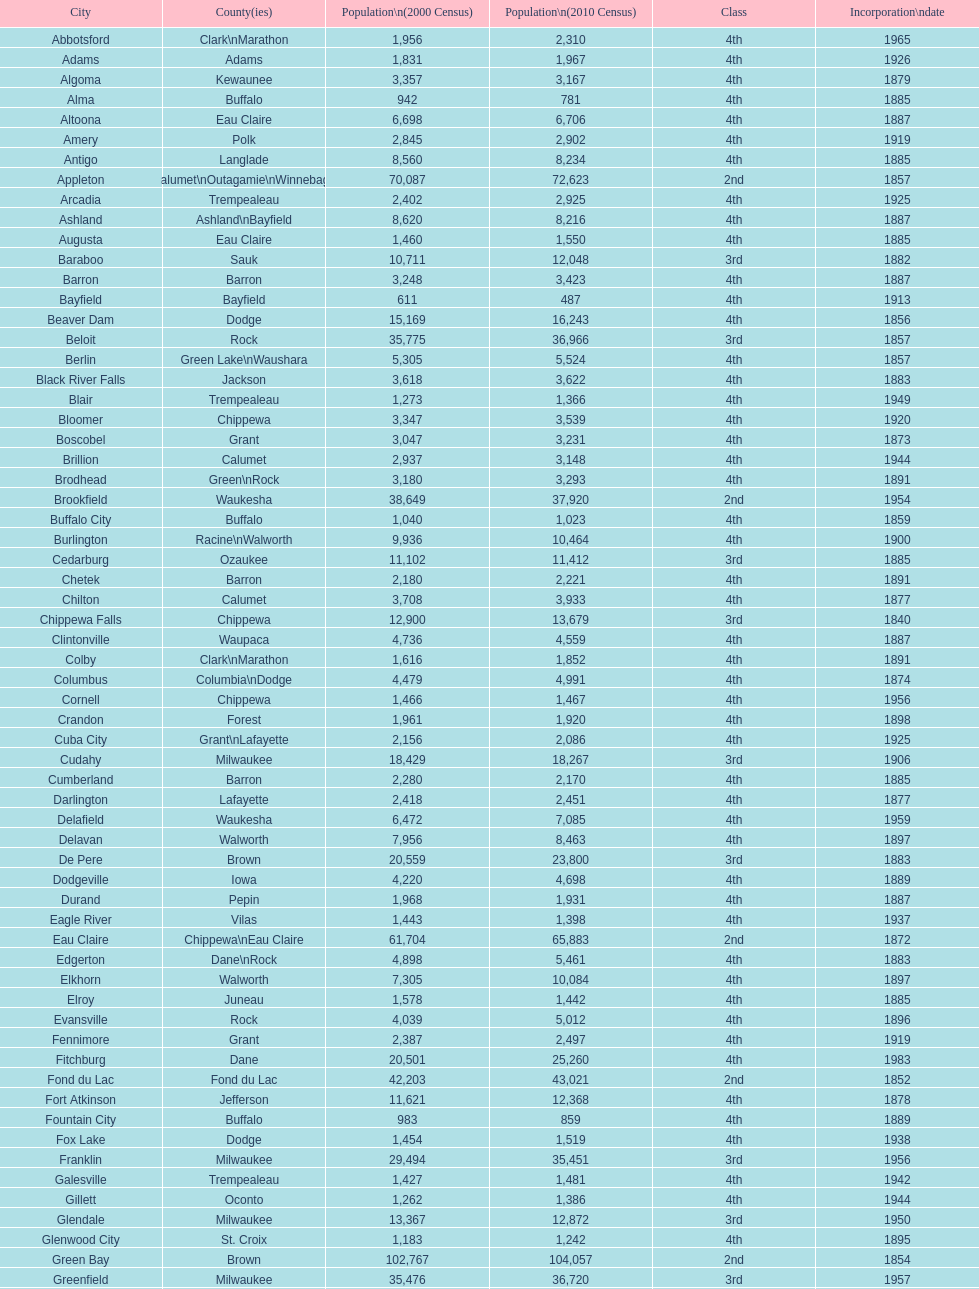What was the first city to be incorporated into wisconsin? Chippewa Falls. Write the full table. {'header': ['City', 'County(ies)', 'Population\\n(2000 Census)', 'Population\\n(2010 Census)', 'Class', 'Incorporation\\ndate'], 'rows': [['Abbotsford', 'Clark\\nMarathon', '1,956', '2,310', '4th', '1965'], ['Adams', 'Adams', '1,831', '1,967', '4th', '1926'], ['Algoma', 'Kewaunee', '3,357', '3,167', '4th', '1879'], ['Alma', 'Buffalo', '942', '781', '4th', '1885'], ['Altoona', 'Eau Claire', '6,698', '6,706', '4th', '1887'], ['Amery', 'Polk', '2,845', '2,902', '4th', '1919'], ['Antigo', 'Langlade', '8,560', '8,234', '4th', '1885'], ['Appleton', 'Calumet\\nOutagamie\\nWinnebago', '70,087', '72,623', '2nd', '1857'], ['Arcadia', 'Trempealeau', '2,402', '2,925', '4th', '1925'], ['Ashland', 'Ashland\\nBayfield', '8,620', '8,216', '4th', '1887'], ['Augusta', 'Eau Claire', '1,460', '1,550', '4th', '1885'], ['Baraboo', 'Sauk', '10,711', '12,048', '3rd', '1882'], ['Barron', 'Barron', '3,248', '3,423', '4th', '1887'], ['Bayfield', 'Bayfield', '611', '487', '4th', '1913'], ['Beaver Dam', 'Dodge', '15,169', '16,243', '4th', '1856'], ['Beloit', 'Rock', '35,775', '36,966', '3rd', '1857'], ['Berlin', 'Green Lake\\nWaushara', '5,305', '5,524', '4th', '1857'], ['Black River Falls', 'Jackson', '3,618', '3,622', '4th', '1883'], ['Blair', 'Trempealeau', '1,273', '1,366', '4th', '1949'], ['Bloomer', 'Chippewa', '3,347', '3,539', '4th', '1920'], ['Boscobel', 'Grant', '3,047', '3,231', '4th', '1873'], ['Brillion', 'Calumet', '2,937', '3,148', '4th', '1944'], ['Brodhead', 'Green\\nRock', '3,180', '3,293', '4th', '1891'], ['Brookfield', 'Waukesha', '38,649', '37,920', '2nd', '1954'], ['Buffalo City', 'Buffalo', '1,040', '1,023', '4th', '1859'], ['Burlington', 'Racine\\nWalworth', '9,936', '10,464', '4th', '1900'], ['Cedarburg', 'Ozaukee', '11,102', '11,412', '3rd', '1885'], ['Chetek', 'Barron', '2,180', '2,221', '4th', '1891'], ['Chilton', 'Calumet', '3,708', '3,933', '4th', '1877'], ['Chippewa Falls', 'Chippewa', '12,900', '13,679', '3rd', '1840'], ['Clintonville', 'Waupaca', '4,736', '4,559', '4th', '1887'], ['Colby', 'Clark\\nMarathon', '1,616', '1,852', '4th', '1891'], ['Columbus', 'Columbia\\nDodge', '4,479', '4,991', '4th', '1874'], ['Cornell', 'Chippewa', '1,466', '1,467', '4th', '1956'], ['Crandon', 'Forest', '1,961', '1,920', '4th', '1898'], ['Cuba City', 'Grant\\nLafayette', '2,156', '2,086', '4th', '1925'], ['Cudahy', 'Milwaukee', '18,429', '18,267', '3rd', '1906'], ['Cumberland', 'Barron', '2,280', '2,170', '4th', '1885'], ['Darlington', 'Lafayette', '2,418', '2,451', '4th', '1877'], ['Delafield', 'Waukesha', '6,472', '7,085', '4th', '1959'], ['Delavan', 'Walworth', '7,956', '8,463', '4th', '1897'], ['De Pere', 'Brown', '20,559', '23,800', '3rd', '1883'], ['Dodgeville', 'Iowa', '4,220', '4,698', '4th', '1889'], ['Durand', 'Pepin', '1,968', '1,931', '4th', '1887'], ['Eagle River', 'Vilas', '1,443', '1,398', '4th', '1937'], ['Eau Claire', 'Chippewa\\nEau Claire', '61,704', '65,883', '2nd', '1872'], ['Edgerton', 'Dane\\nRock', '4,898', '5,461', '4th', '1883'], ['Elkhorn', 'Walworth', '7,305', '10,084', '4th', '1897'], ['Elroy', 'Juneau', '1,578', '1,442', '4th', '1885'], ['Evansville', 'Rock', '4,039', '5,012', '4th', '1896'], ['Fennimore', 'Grant', '2,387', '2,497', '4th', '1919'], ['Fitchburg', 'Dane', '20,501', '25,260', '4th', '1983'], ['Fond du Lac', 'Fond du Lac', '42,203', '43,021', '2nd', '1852'], ['Fort Atkinson', 'Jefferson', '11,621', '12,368', '4th', '1878'], ['Fountain City', 'Buffalo', '983', '859', '4th', '1889'], ['Fox Lake', 'Dodge', '1,454', '1,519', '4th', '1938'], ['Franklin', 'Milwaukee', '29,494', '35,451', '3rd', '1956'], ['Galesville', 'Trempealeau', '1,427', '1,481', '4th', '1942'], ['Gillett', 'Oconto', '1,262', '1,386', '4th', '1944'], ['Glendale', 'Milwaukee', '13,367', '12,872', '3rd', '1950'], ['Glenwood City', 'St. Croix', '1,183', '1,242', '4th', '1895'], ['Green Bay', 'Brown', '102,767', '104,057', '2nd', '1854'], ['Greenfield', 'Milwaukee', '35,476', '36,720', '3rd', '1957'], ['Green Lake', 'Green Lake', '1,100', '960', '4th', '1962'], ['Greenwood', 'Clark', '1,079', '1,026', '4th', '1891'], ['Hartford', 'Dodge\\nWashington', '10,905', '14,223', '3rd', '1883'], ['Hayward', 'Sawyer', '2,129', '2,318', '4th', '1915'], ['Hillsboro', 'Vernon', '1,302', '1,417', '4th', '1885'], ['Horicon', 'Dodge', '3,775', '3,655', '4th', '1897'], ['Hudson', 'St. Croix', '8,775', '12,719', '4th', '1858'], ['Hurley', 'Iron', '1,818', '1,547', '4th', '1918'], ['Independence', 'Trempealeau', '1,244', '1,336', '4th', '1942'], ['Janesville', 'Rock', '59,498', '63,575', '2nd', '1853'], ['Jefferson', 'Jefferson', '7,338', '7,973', '4th', '1878'], ['Juneau', 'Dodge', '2,485', '2,814', '4th', '1887'], ['Kaukauna', 'Outagamie', '12,983', '15,462', '3rd', '1885'], ['Kenosha', 'Kenosha', '90,352', '99,218', '2nd', '1850'], ['Kewaunee', 'Kewaunee', '2,806', '2,952', '4th', '1883'], ['Kiel', 'Calumet\\nManitowoc', '3,450', '3,738', '4th', '1920'], ['La Crosse', 'La Crosse', '51,818', '51,320', '2nd', '1856'], ['Ladysmith', 'Rusk', '3,932', '3,414', '4th', '1905'], ['Lake Geneva', 'Walworth', '7,148', '7,651', '4th', '1883'], ['Lake Mills', 'Jefferson', '4,843', '5,708', '4th', '1905'], ['Lancaster', 'Grant', '4,070', '3,868', '4th', '1878'], ['Lodi', 'Columbia', '2,882', '3,050', '4th', '1941'], ['Loyal', 'Clark', '1,308', '1,261', '4th', '1948'], ['Madison', 'Dane', '208,054', '233,209', '2nd', '1856'], ['Manawa', 'Waupaca', '1,330', '1,371', '4th', '1954'], ['Manitowoc', 'Manitowoc', '34,053', '33,736', '3rd', '1870'], ['Marinette', 'Marinette', '11,749', '10,968', '3rd', '1887'], ['Marion', 'Shawano\\nWaupaca', '1,297', '1,260', '4th', '1898'], ['Markesan', 'Green Lake', '1,396', '1,476', '4th', '1959'], ['Marshfield', 'Marathon\\nWood', '18,800', '19,118', '3rd', '1883'], ['Mauston', 'Juneau', '3,740', '4,423', '4th', '1883'], ['Mayville', 'Dodge', '4,902', '5,154', '4th', '1885'], ['Medford', 'Taylor', '4,350', '4,326', '4th', '1889'], ['Mellen', 'Ashland', '845', '731', '4th', '1907'], ['Menasha', 'Calumet\\nWinnebago', '16,331', '17,353', '3rd', '1874'], ['Menomonie', 'Dunn', '14,937', '16,264', '4th', '1882'], ['Mequon', 'Ozaukee', '22,643', '23,132', '4th', '1957'], ['Merrill', 'Lincoln', '10,146', '9,661', '4th', '1883'], ['Middleton', 'Dane', '15,770', '17,442', '3rd', '1963'], ['Milton', 'Rock', '5,132', '5,546', '4th', '1969'], ['Milwaukee', 'Milwaukee\\nWashington\\nWaukesha', '596,974', '594,833', '1st', '1846'], ['Mineral Point', 'Iowa', '2,617', '2,487', '4th', '1857'], ['Mondovi', 'Buffalo', '2,634', '2,777', '4th', '1889'], ['Monona', 'Dane', '8,018', '7,533', '4th', '1969'], ['Monroe', 'Green', '10,843', '10,827', '4th', '1882'], ['Montello', 'Marquette', '1,397', '1,495', '4th', '1938'], ['Montreal', 'Iron', '838', '807', '4th', '1924'], ['Mosinee', 'Marathon', '4,063', '3,988', '4th', '1931'], ['Muskego', 'Waukesha', '21,397', '24,135', '3rd', '1964'], ['Neenah', 'Winnebago', '24,507', '25,501', '3rd', '1873'], ['Neillsville', 'Clark', '2,731', '2,463', '4th', '1882'], ['Nekoosa', 'Wood', '2,590', '2,580', '4th', '1926'], ['New Berlin', 'Waukesha', '38,220', '39,584', '3rd', '1959'], ['New Holstein', 'Calumet', '3,301', '3,236', '4th', '1889'], ['New Lisbon', 'Juneau', '1,436', '2,554', '4th', '1889'], ['New London', 'Outagamie\\nWaupaca', '7,085', '7,295', '4th', '1877'], ['New Richmond', 'St. Croix', '6,310', '8,375', '4th', '1885'], ['Niagara', 'Marinette', '1,880', '1,624', '4th', '1992'], ['Oak Creek', 'Milwaukee', '28,456', '34,451', '3rd', '1955'], ['Oconomowoc', 'Waukesha', '12,382', '15,712', '3rd', '1875'], ['Oconto', 'Oconto', '4,708', '4,513', '4th', '1869'], ['Oconto Falls', 'Oconto', '2,843', '2,891', '4th', '1919'], ['Omro', 'Winnebago', '3,177', '3,517', '4th', '1944'], ['Onalaska', 'La Crosse', '14,839', '17,736', '4th', '1887'], ['Oshkosh', 'Winnebago', '62,916', '66,083', '2nd', '1853'], ['Osseo', 'Trempealeau', '1,669', '1,701', '4th', '1941'], ['Owen', 'Clark', '936', '940', '4th', '1925'], ['Park Falls', 'Price', '2,739', '2,462', '4th', '1912'], ['Peshtigo', 'Marinette', '3,474', '3,502', '4th', '1903'], ['Pewaukee', 'Waukesha', '11,783', '13,195', '3rd', '1999'], ['Phillips', 'Price', '1,675', '1,478', '4th', '1891'], ['Pittsville', 'Wood', '866', '874', '4th', '1887'], ['Platteville', 'Grant', '9,989', '11,224', '4th', '1876'], ['Plymouth', 'Sheboygan', '7,781', '8,445', '4th', '1877'], ['Port Washington', 'Ozaukee', '10,467', '11,250', '4th', '1882'], ['Portage', 'Columbia', '9,728', '10,324', '4th', '1854'], ['Prairie du Chien', 'Crawford', '6,018', '5,911', '4th', '1872'], ['Prescott', 'Pierce', '3,764', '4,258', '4th', '1857'], ['Princeton', 'Green Lake', '1,504', '1,214', '4th', '1920'], ['Racine', 'Racine', '81,855', '78,860', '2nd', '1848'], ['Reedsburg', 'Sauk', '7,827', '10,014', '4th', '1887'], ['Rhinelander', 'Oneida', '7,735', '7,798', '4th', '1894'], ['Rice Lake', 'Barron', '8,312', '8,438', '4th', '1887'], ['Richland Center', 'Richland', '5,114', '5,184', '4th', '1887'], ['Ripon', 'Fond du Lac', '7,450', '7,733', '4th', '1858'], ['River Falls', 'Pierce\\nSt. Croix', '12,560', '15,000', '3rd', '1875'], ['St. Croix Falls', 'Polk', '2,033', '2,133', '4th', '1958'], ['St. Francis', 'Milwaukee', '8,662', '9,365', '4th', '1951'], ['Schofield', 'Marathon', '2,117', '2,169', '4th', '1951'], ['Seymour', 'Outagamie', '3,335', '3,451', '4th', '1879'], ['Shawano', 'Shawano', '8,298', '9,305', '4th', '1874'], ['Sheboygan', 'Sheboygan', '50,792', '49,288', '2nd', '1853'], ['Sheboygan Falls', 'Sheboygan', '6,772', '7,775', '4th', '1913'], ['Shell Lake', 'Washburn', '1,309', '1,347', '4th', '1961'], ['Shullsburg', 'Lafayette', '1,246', '1,226', '4th', '1889'], ['South Milwaukee', 'Milwaukee', '21,256', '21,156', '4th', '1897'], ['Sparta', 'Monroe', '8,648', '9,522', '4th', '1883'], ['Spooner', 'Washburn', '2,653', '2,682', '4th', '1909'], ['Stanley', 'Chippewa\\nClark', '1,898', '3,608', '4th', '1898'], ['Stevens Point', 'Portage', '24,551', '26,717', '3rd', '1858'], ['Stoughton', 'Dane', '12,354', '12,611', '4th', '1882'], ['Sturgeon Bay', 'Door', '9,437', '9,144', '4th', '1883'], ['Sun Prairie', 'Dane', '20,369', '29,364', '3rd', '1958'], ['Superior', 'Douglas', '27,368', '27,244', '2nd', '1858'], ['Thorp', 'Clark', '1,536', '1,621', '4th', '1948'], ['Tomah', 'Monroe', '8,419', '9,093', '4th', '1883'], ['Tomahawk', 'Lincoln', '3,770', '3,397', '4th', '1891'], ['Two Rivers', 'Manitowoc', '12,639', '11,712', '3rd', '1878'], ['Verona', 'Dane', '7,052', '10,619', '4th', '1977'], ['Viroqua', 'Vernon', '4,335', '5,079', '4th', '1885'], ['Washburn', 'Bayfield', '2,280', '2,117', '4th', '1904'], ['Waterloo', 'Jefferson', '3,259', '3,333', '4th', '1962'], ['Watertown', 'Dodge\\nJefferson', '21,598', '23,861', '3rd', '1853'], ['Waukesha', 'Waukesha', '64,825', '70,718', '2nd', '1895'], ['Waupaca', 'Waupaca', '5,676', '6,069', '4th', '1878'], ['Waupun', 'Dodge\\nFond du Lac', '10,944', '11,340', '4th', '1878'], ['Wausau', 'Marathon', '38,426', '39,106', '3rd', '1872'], ['Wautoma', 'Waushara', '1,998', '2,218', '4th', '1901'], ['Wauwatosa', 'Milwaukee', '47,271', '46,396', '2nd', '1897'], ['West Allis', 'Milwaukee', '61,254', '60,411', '2nd', '1906'], ['West Bend', 'Washington', '28,152', '31,078', '3rd', '1885'], ['Westby', 'Vernon', '2,045', '2,200', '4th', '1920'], ['Weyauwega', 'Waupaca', '1,806', '1,900', '4th', '1939'], ['Whitehall', 'Trempealeau', '1,651', '1,558', '4th', '1941'], ['Whitewater', 'Jefferson\\nWalworth', '13,437', '14,390', '4th', '1885'], ['Wisconsin Dells', 'Adams\\nColumbia\\nJuneau\\nSauk', '2,418', '2,678', '4th', '1925'], ['Wisconsin Rapids', 'Wood', '18,435', '18,367', '3rd', '1869']]} 